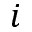Convert formula to latex. <formula><loc_0><loc_0><loc_500><loc_500>i</formula> 